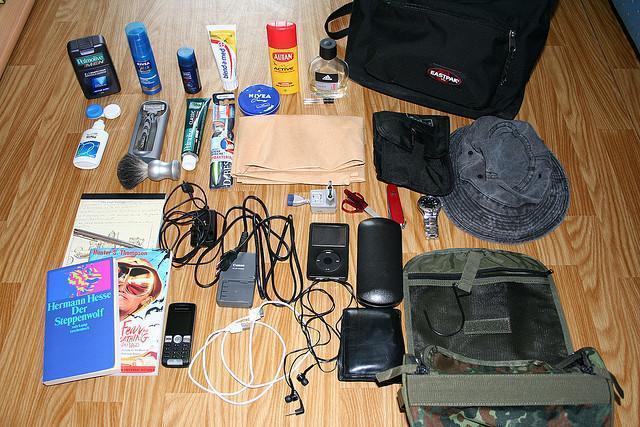How many handbags are there?
Give a very brief answer. 2. How many books are there?
Give a very brief answer. 3. How many remotes are in the picture?
Give a very brief answer. 2. How many cows are looking at the camera?
Give a very brief answer. 0. 